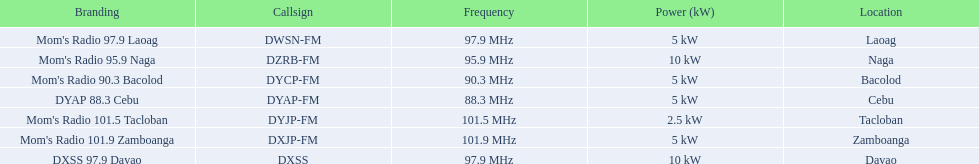What is the power capacity in kw for each team? 5 kW, 10 kW, 5 kW, 5 kW, 2.5 kW, 5 kW, 10 kW. Which is the lowest? 2.5 kW. What station has this amount of power? Mom's Radio 101.5 Tacloban. Can you give me this table in json format? {'header': ['Branding', 'Callsign', 'Frequency', 'Power (kW)', 'Location'], 'rows': [["Mom's Radio 97.9 Laoag", 'DWSN-FM', '97.9\xa0MHz', '5\xa0kW', 'Laoag'], ["Mom's Radio 95.9 Naga", 'DZRB-FM', '95.9\xa0MHz', '10\xa0kW', 'Naga'], ["Mom's Radio 90.3 Bacolod", 'DYCP-FM', '90.3\xa0MHz', '5\xa0kW', 'Bacolod'], ['DYAP 88.3 Cebu', 'DYAP-FM', '88.3\xa0MHz', '5\xa0kW', 'Cebu'], ["Mom's Radio 101.5 Tacloban", 'DYJP-FM', '101.5\xa0MHz', '2.5\xa0kW', 'Tacloban'], ["Mom's Radio 101.9 Zamboanga", 'DXJP-FM', '101.9\xa0MHz', '5\xa0kW', 'Zamboanga'], ['DXSS 97.9 Davao', 'DXSS', '97.9\xa0MHz', '10\xa0kW', 'Davao']]} 